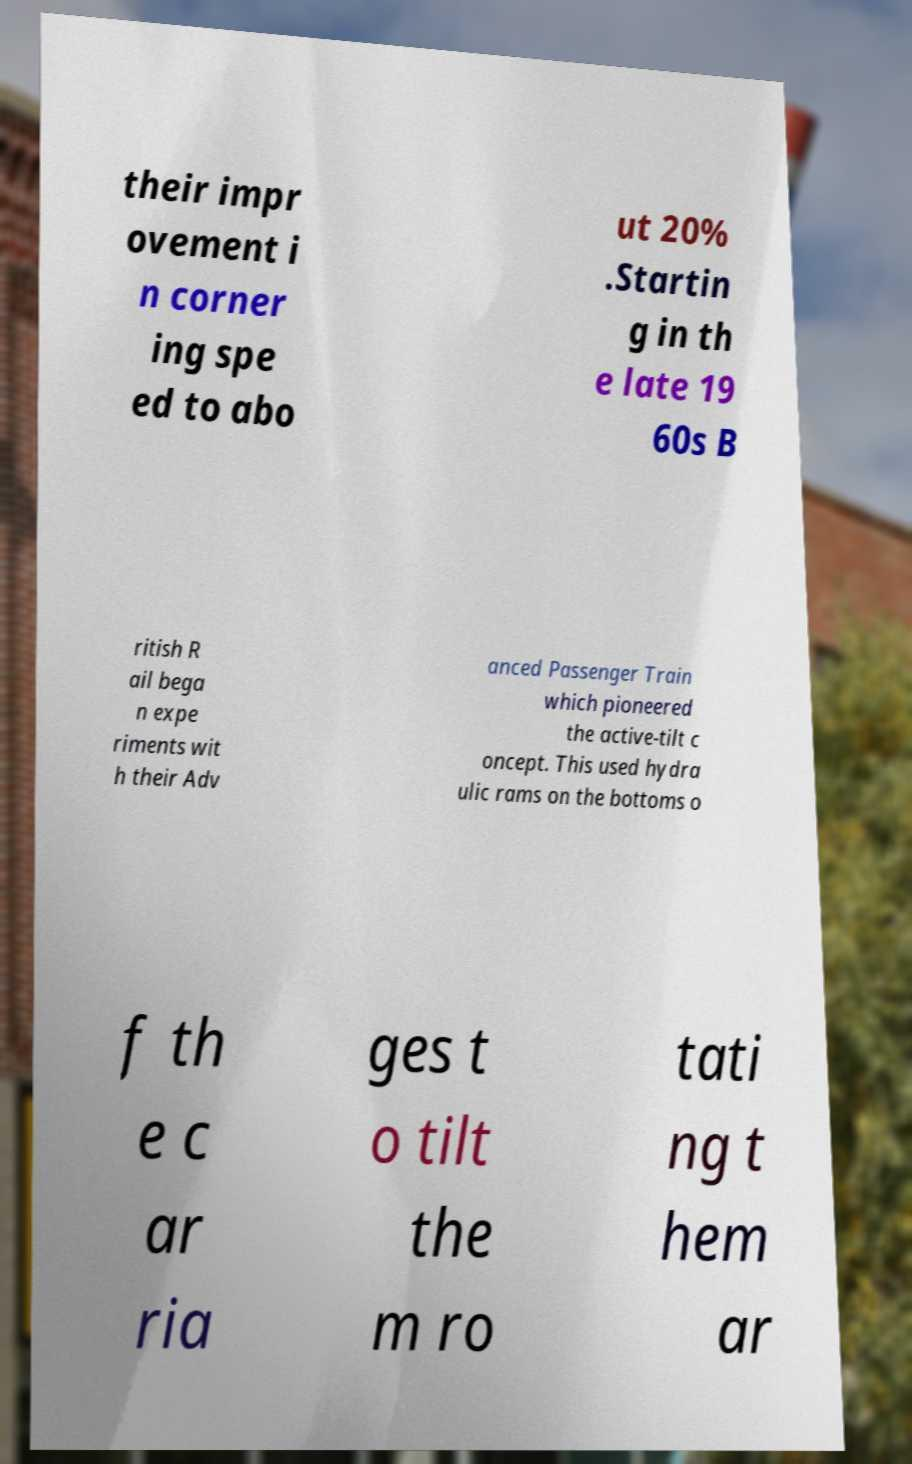Please read and relay the text visible in this image. What does it say? their impr ovement i n corner ing spe ed to abo ut 20% .Startin g in th e late 19 60s B ritish R ail bega n expe riments wit h their Adv anced Passenger Train which pioneered the active-tilt c oncept. This used hydra ulic rams on the bottoms o f th e c ar ria ges t o tilt the m ro tati ng t hem ar 